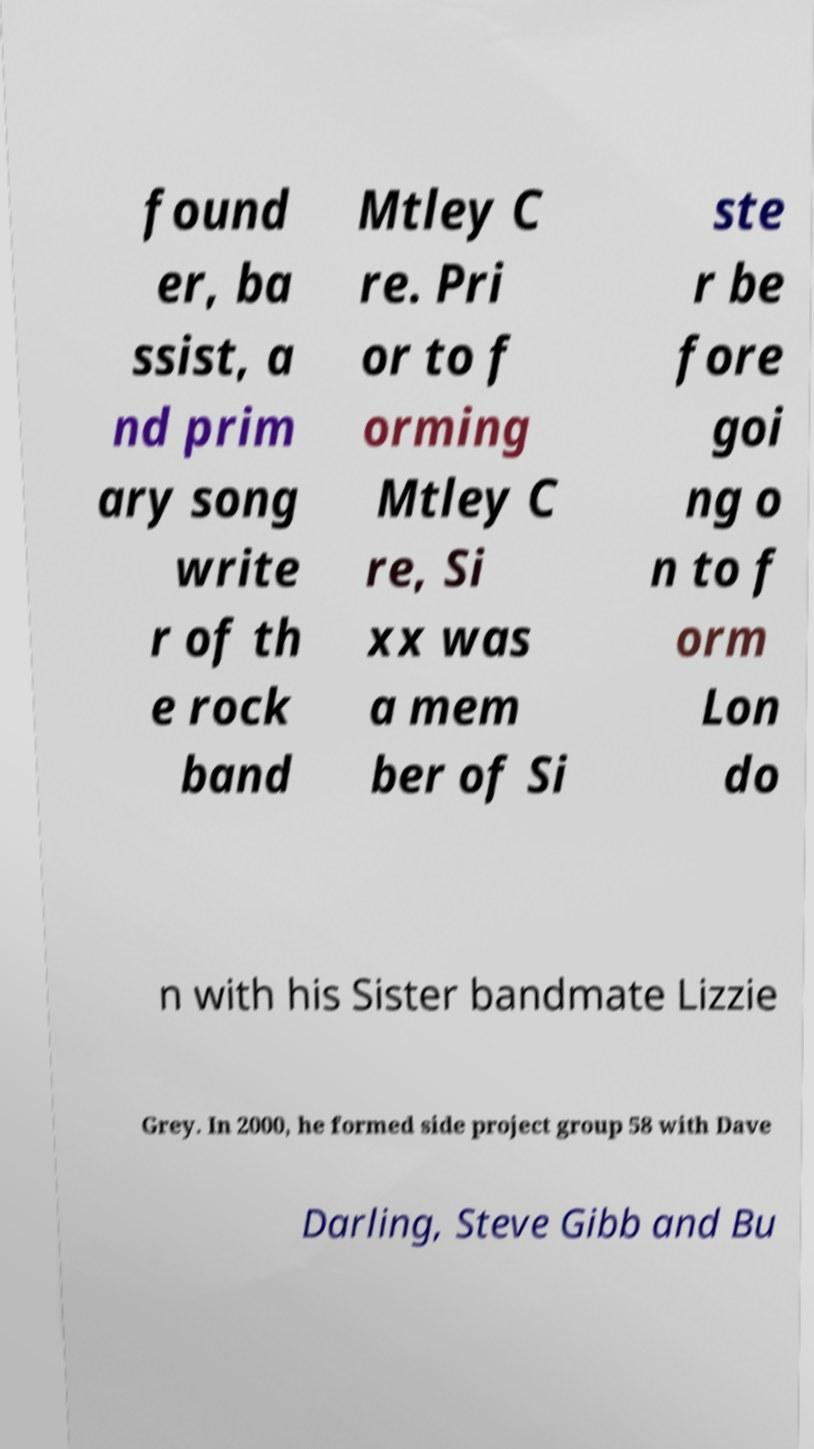For documentation purposes, I need the text within this image transcribed. Could you provide that? found er, ba ssist, a nd prim ary song write r of th e rock band Mtley C re. Pri or to f orming Mtley C re, Si xx was a mem ber of Si ste r be fore goi ng o n to f orm Lon do n with his Sister bandmate Lizzie Grey. In 2000, he formed side project group 58 with Dave Darling, Steve Gibb and Bu 